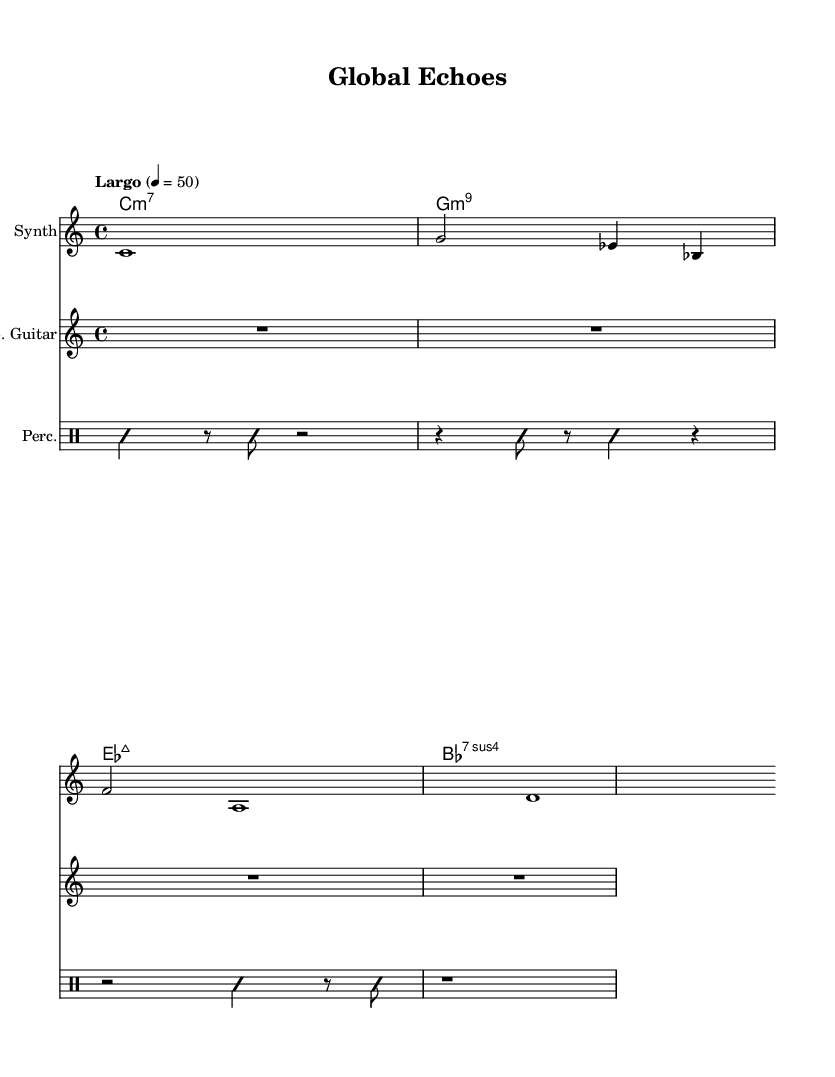What is the time signature of this music? The time signature is 4/4, indicated at the beginning of the score. It shows that there are four beats per measure and the quarter note gets one beat.
Answer: 4/4 What is the tempo marking given in the score? The tempo marking is "Largo" with a metronome setting of 50 beats per minute. This indicates a slow pace for the piece.
Answer: Largo, 50 How many measures are in the synthesizer part? The synthesizer part contains three measures, which can be counted from the notation shown.
Answer: 3 What instrument plays the improvisational rhythm? The improvisational rhythm is played by the percussion, as indicated by the labeled staff and the improvisation markings in the score.
Answer: Percussion What chord is written in the first measure of the chord names? The first measure of the chord names shows the chord C minor 7, which corresponds to the chord notation provided.
Answer: C minor 7 How is silence represented in the percussion part? Silence in the percussion part is indicated by the use of rests, such as the quarter note rests displayed in the notation.
Answer: Rests What is unique about the guitar part in this score? The electric guitar part is marked with a rest for the entire duration, indicating that it does not play any notes in this section, which is characteristic of ambient music.
Answer: It plays no notes 